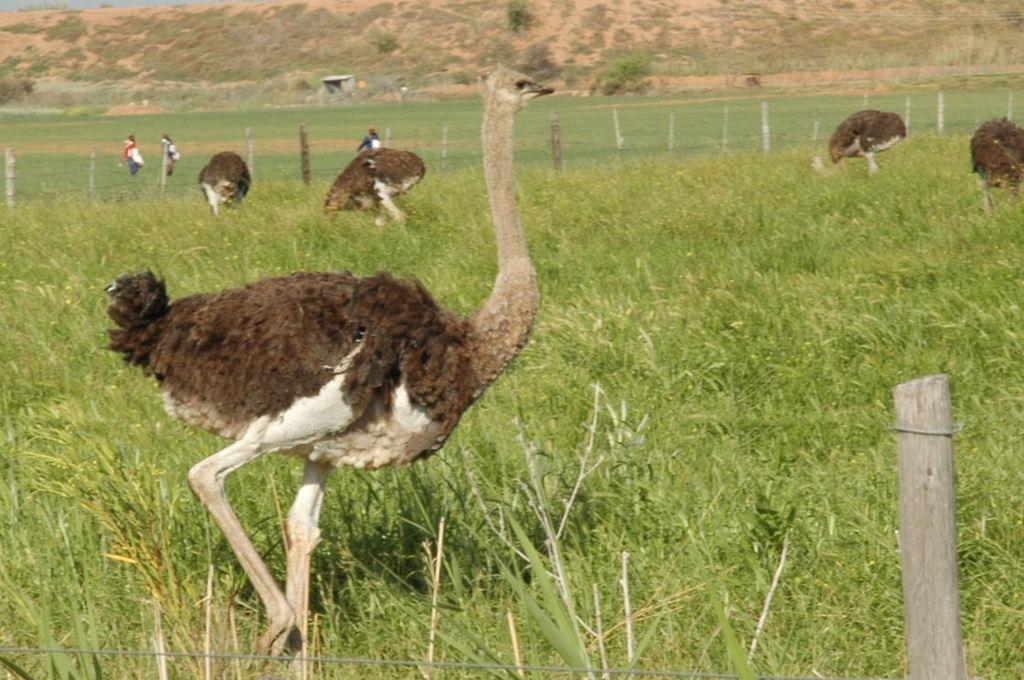Could you give a brief overview of what you see in this image? Here we can see birds and there are persons. This is grass and there is a fence. And there are plants. 